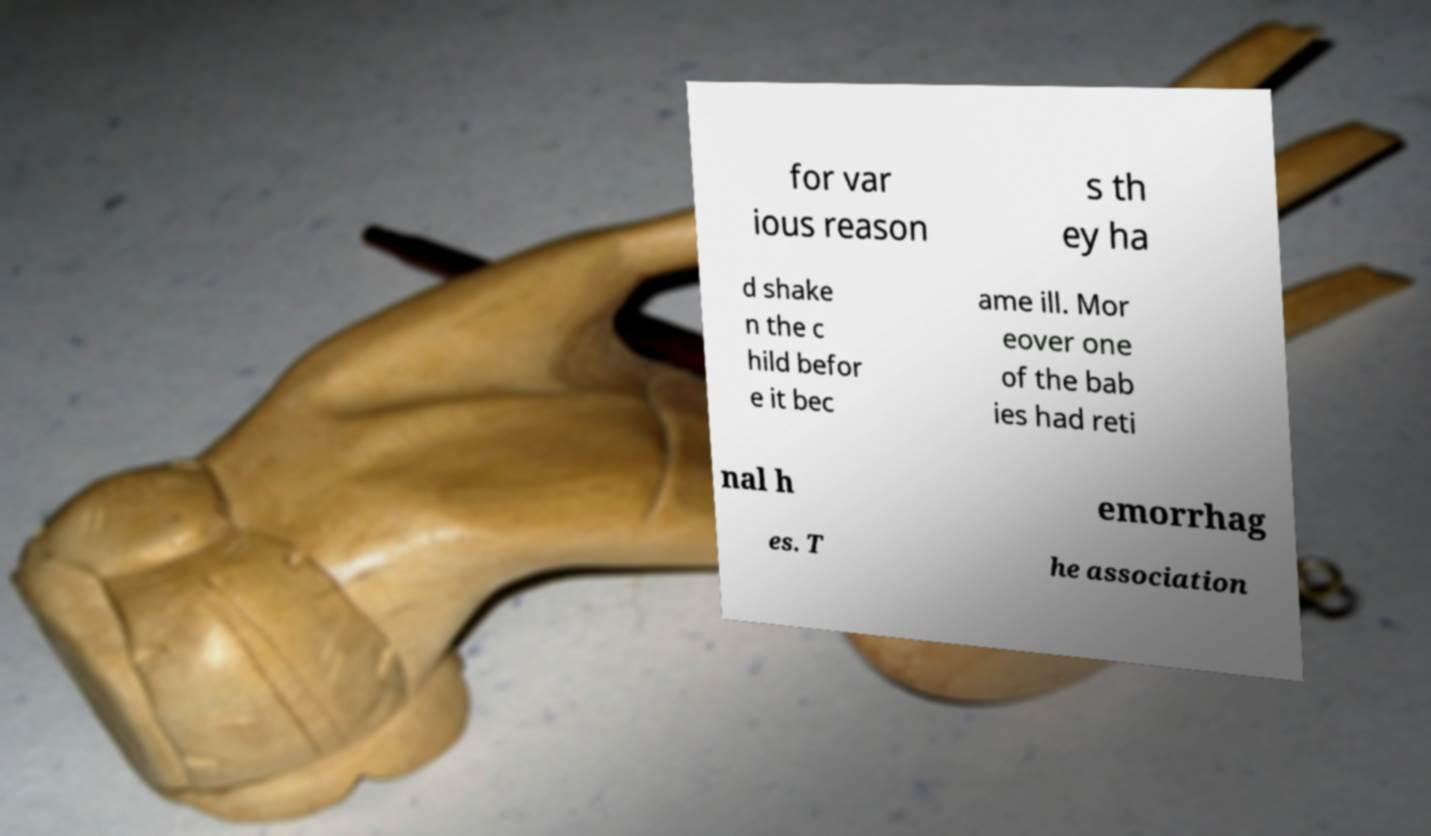Can you accurately transcribe the text from the provided image for me? for var ious reason s th ey ha d shake n the c hild befor e it bec ame ill. Mor eover one of the bab ies had reti nal h emorrhag es. T he association 